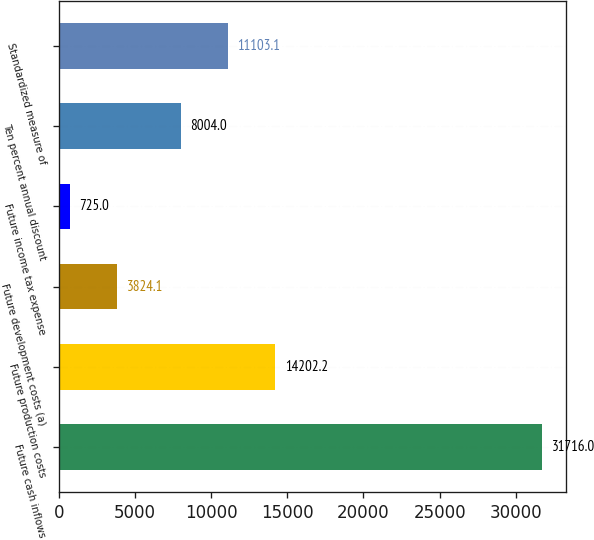<chart> <loc_0><loc_0><loc_500><loc_500><bar_chart><fcel>Future cash inflows<fcel>Future production costs<fcel>Future development costs (a)<fcel>Future income tax expense<fcel>Ten percent annual discount<fcel>Standardized measure of<nl><fcel>31716<fcel>14202.2<fcel>3824.1<fcel>725<fcel>8004<fcel>11103.1<nl></chart> 